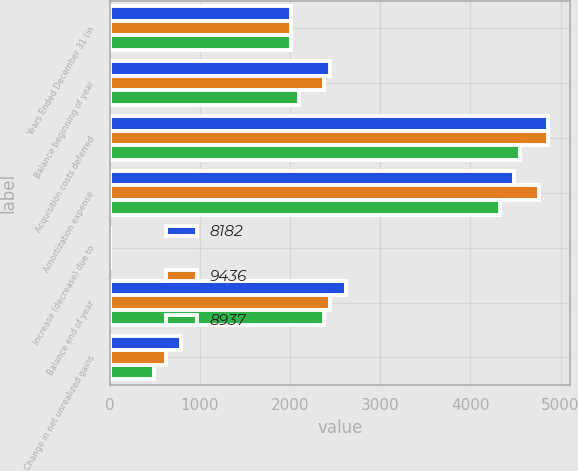Convert chart. <chart><loc_0><loc_0><loc_500><loc_500><stacked_bar_chart><ecel><fcel>Years Ended December 31 (in<fcel>Balance beginning of year<fcel>Acquisition costs deferred<fcel>Amortization expense<fcel>Increase (decrease) due to<fcel>Balance end of year<fcel>Change in net unrealized gains<nl><fcel>8182<fcel>2013<fcel>2441<fcel>4866<fcel>4479<fcel>5<fcel>2623<fcel>787<nl><fcel>9436<fcel>2012<fcel>2375<fcel>4861<fcel>4761<fcel>2<fcel>2441<fcel>621<nl><fcel>8937<fcel>2011<fcel>2099<fcel>4548<fcel>4324<fcel>3<fcel>2375<fcel>486<nl></chart> 